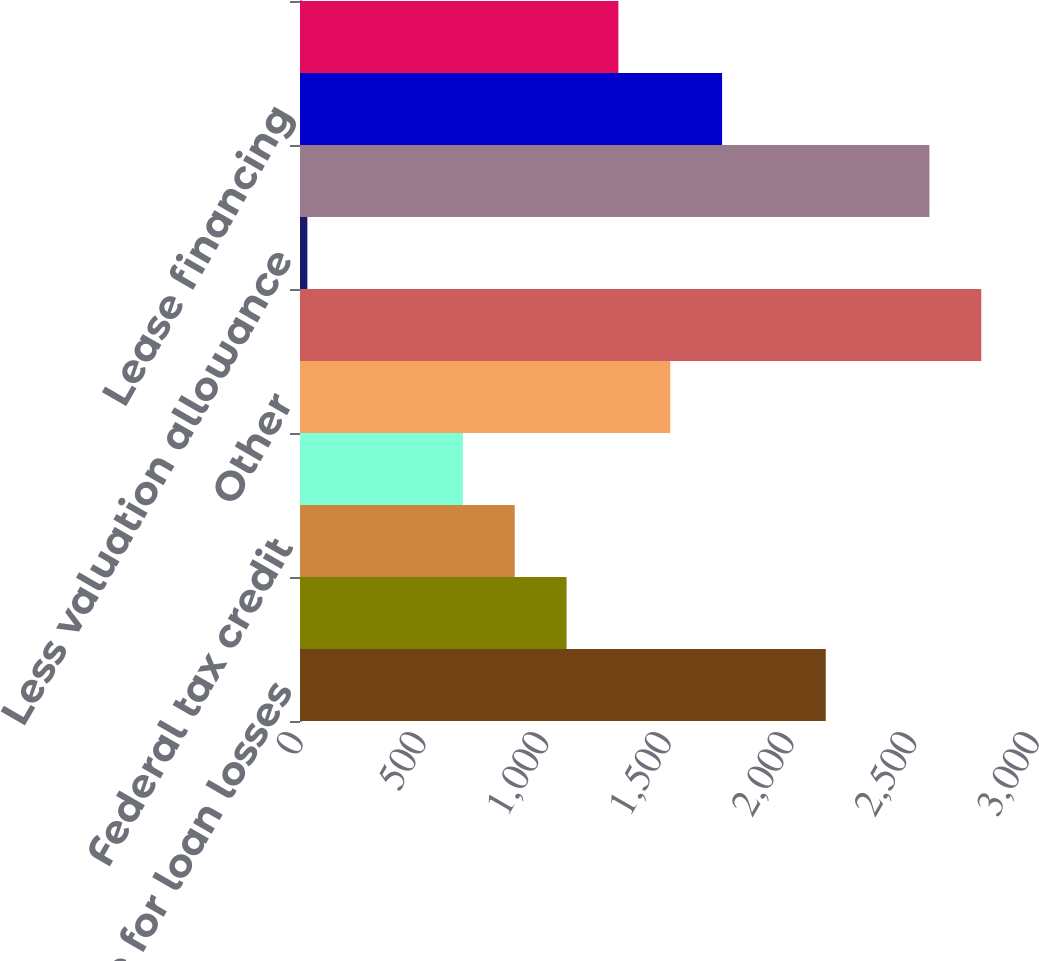<chart> <loc_0><loc_0><loc_500><loc_500><bar_chart><fcel>Allowance for loan losses<fcel>Net operating loss<fcel>Federal tax credit<fcel>Employee benefits and deferred<fcel>Other<fcel>Total deferred tax assets<fcel>Less valuation allowance<fcel>Total deferred tax assets less<fcel>Lease financing<fcel>Goodwill and intangibles<nl><fcel>2143<fcel>1086.5<fcel>875.2<fcel>663.9<fcel>1509.1<fcel>2776.9<fcel>30<fcel>2565.6<fcel>1720.4<fcel>1297.8<nl></chart> 